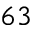<formula> <loc_0><loc_0><loc_500><loc_500>6 3</formula> 